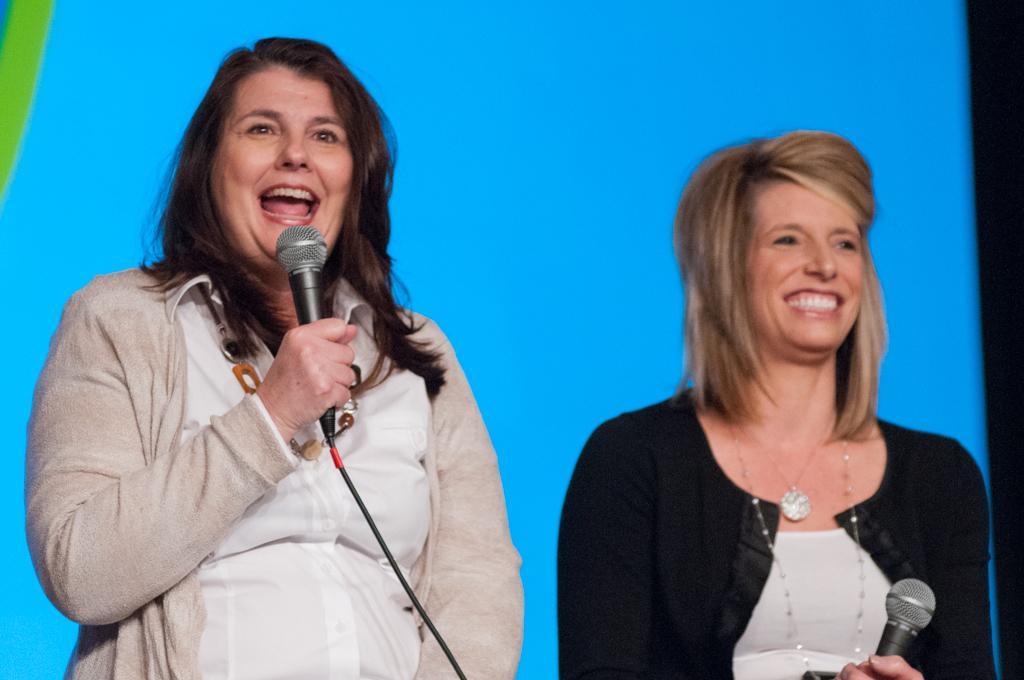Describe this image in one or two sentences. This picture shows a two women standing and both of them were smiling. There two mics in their hands. In the background there is blue colored screen. 